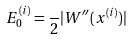<formula> <loc_0><loc_0><loc_500><loc_500>E _ { 0 } ^ { ( i ) } = \frac { } { 2 } | W ^ { \prime \prime } ( x ^ { ( i ) } ) |</formula> 